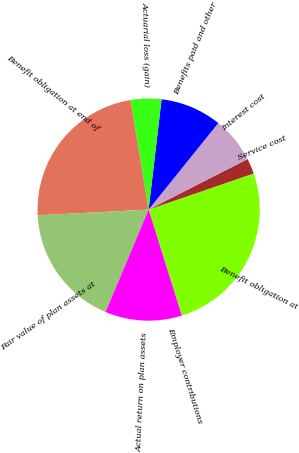Convert chart to OTSL. <chart><loc_0><loc_0><loc_500><loc_500><pie_chart><fcel>Benefit obligation at<fcel>Service cost<fcel>Interest cost<fcel>Benefits paid and other<fcel>Actuarial loss (gain)<fcel>Benefit obligation at end of<fcel>Fair value of plan assets at<fcel>Actual return on plan assets<fcel>Employer contributions<nl><fcel>25.44%<fcel>2.24%<fcel>6.7%<fcel>8.93%<fcel>4.47%<fcel>23.21%<fcel>17.85%<fcel>11.16%<fcel>0.01%<nl></chart> 